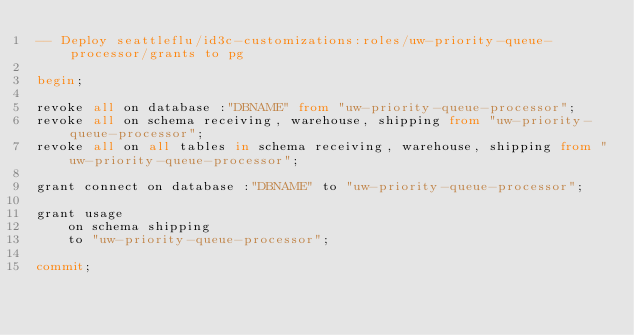<code> <loc_0><loc_0><loc_500><loc_500><_SQL_>-- Deploy seattleflu/id3c-customizations:roles/uw-priority-queue-processor/grants to pg

begin;

revoke all on database :"DBNAME" from "uw-priority-queue-processor";
revoke all on schema receiving, warehouse, shipping from "uw-priority-queue-processor";
revoke all on all tables in schema receiving, warehouse, shipping from "uw-priority-queue-processor";

grant connect on database :"DBNAME" to "uw-priority-queue-processor";

grant usage
    on schema shipping
    to "uw-priority-queue-processor";

commit;
</code> 